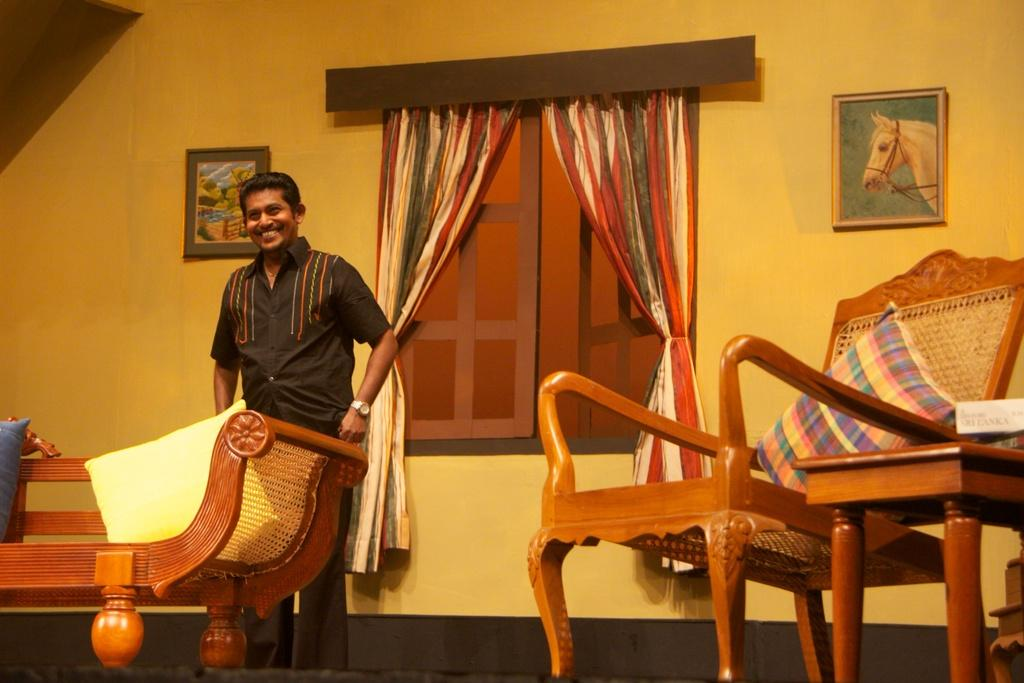Who or what is present in the image? There is a person in the image. What is the person wearing? The person is wearing a black shirt. What is the person standing behind? The person is standing behind a wooden sofa. What is located beside the person? There is a chair beside the person. What can be seen behind the person? There is a window behind the person. What type of maid is performing an act on the wooden sofa in the image? There is no maid or act being performed on the wooden sofa in the image. The person is simply standing behind it. 